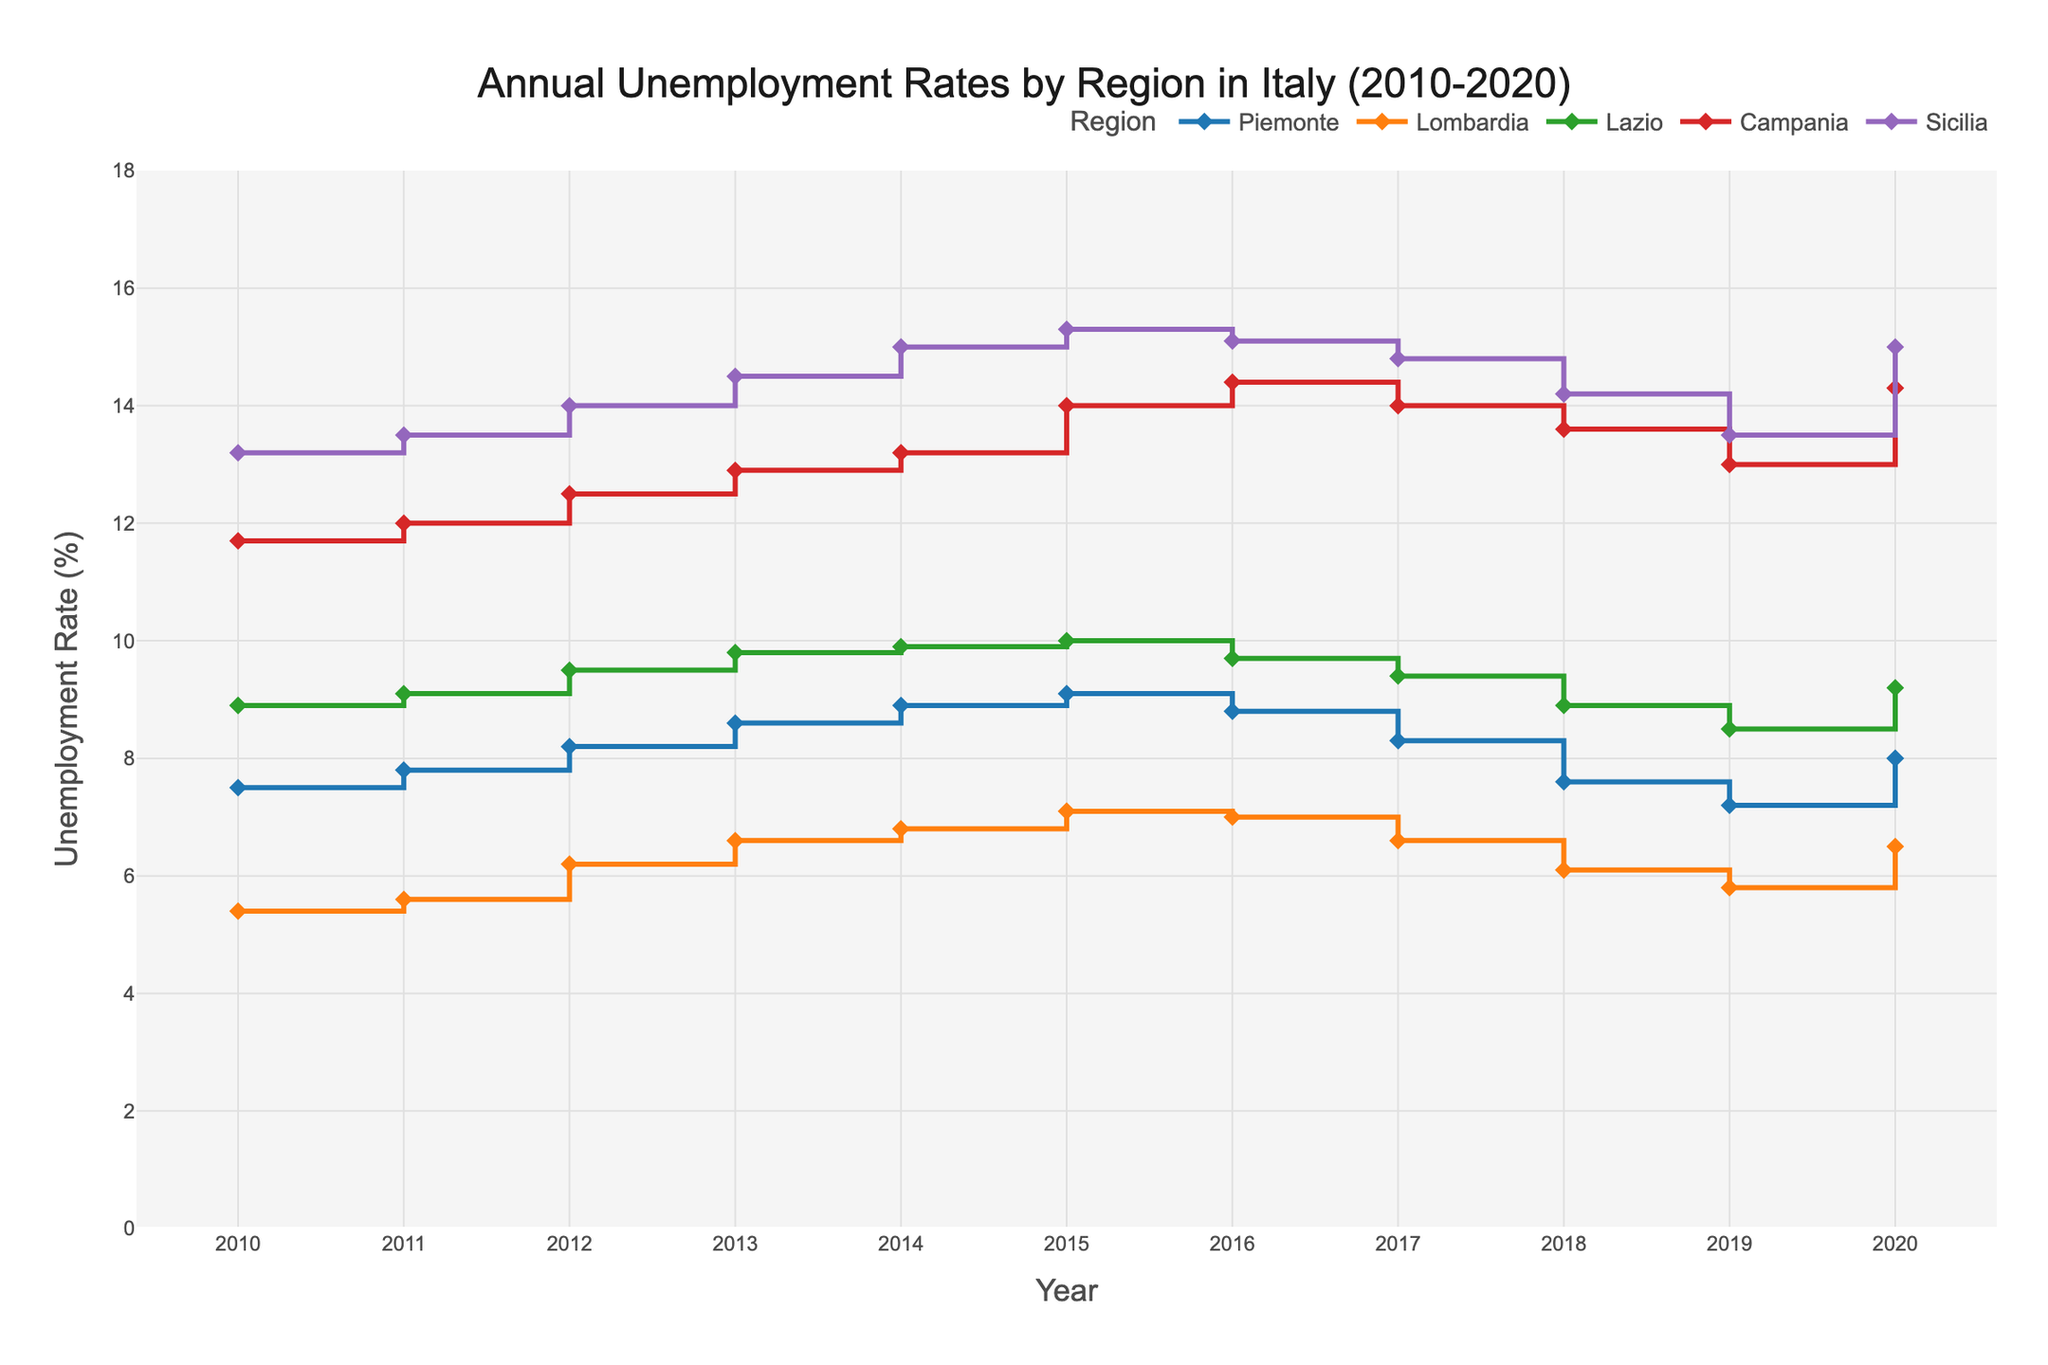What is the unemployment rate in Piemonte in 2015? Look for the data point on the plot where the region is Piemonte and the year is 2015. The corresponding unemployment rate is indicated by the height of the stair.
Answer: 9.1 Which region had the highest unemployment rate in 2020? Check the data points for each region in the year 2020 and compare their heights. The highest point corresponds to the highest unemployment rate.
Answer: Sicilia How does the unemployment trend in Lombardia from 2010 to 2020 compare to that in Lazio? Observe and compare the directional changes of the stair lines for Lombardia and Lazio from 2010 to 2020. Lombardia shows general stability with minor fluctuations, whereas Lazio saw a decline after 2016 until it rises in 2020.
Answer: Lombardia shows a more stable trend Between 2010 and 2020, which region saw the largest increase in unemployment rate? Determine the difference between the unemployment rates in 2010 and 2020 for each region. The region with the highest difference experienced the largest increase. Sicilia's rate increased from 13.2% to 15.0%.
Answer: Sicilia In which year did Campania have its peak unemployment rate, and what was it? Identify the highest point on the stair line for Campania and check its corresponding year.
Answer: 2016, 14.4 Which regions had their lowest unemployment rates in 2019? Find the lowest data points for each region and verify their corresponding year.
Answer: Piemonte, Lombardia, Lazio, and Sicilia What was the average unemployment rate in Piemonte over this period? Sum the unemployment rates in Piemonte from 2010 to 2020 and divide by the number of years (11). \((7.5 + 7.8 + 8.2 + 8.6 + 8.9 + 9.1 + 8.8 + 8.3 + 7.6 + 7.2 + 8.0) / 11 = 8.2\)
Answer: 8.2 